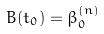Convert formula to latex. <formula><loc_0><loc_0><loc_500><loc_500>B ( t _ { 0 } ) = \beta _ { 0 } ^ { ( n ) }</formula> 